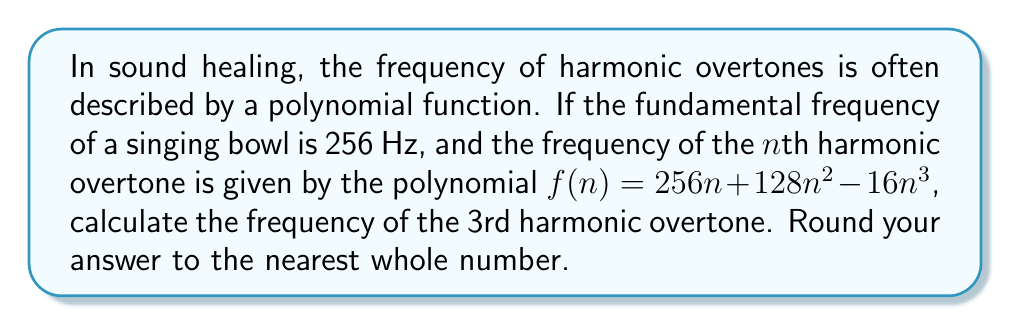Show me your answer to this math problem. To solve this problem, we need to follow these steps:

1. Identify the given information:
   - The fundamental frequency is 256 Hz
   - The polynomial function for the nth harmonic overtone is:
     $$f(n) = 256n + 128n^2 - 16n^3$$
   - We need to find the frequency of the 3rd harmonic overtone

2. Substitute n = 3 into the polynomial function:
   $$f(3) = 256(3) + 128(3)^2 - 16(3)^3$$

3. Simplify the expression:
   $$f(3) = 768 + 128(9) - 16(27)$$
   $$f(3) = 768 + 1152 - 432$$

4. Perform the arithmetic:
   $$f(3) = 1920 + (-432)$$
   $$f(3) = 1488$$

5. Round to the nearest whole number:
   The result is already a whole number, so no rounding is necessary.

This calculation reveals that the 3rd harmonic overtone in this sound healing context has a frequency of 1488 Hz, which is approximately 5.8 times the fundamental frequency. This relationship between harmonics is crucial in understanding the rich, complex tones used in sound healing practices.
Answer: 1488 Hz 